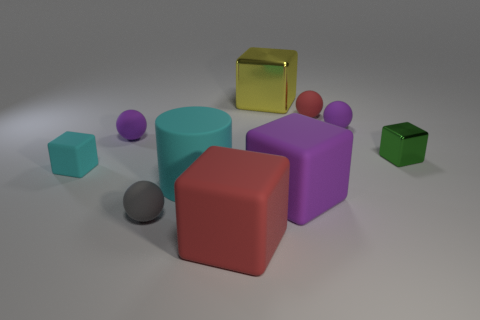What is the color of the small metal cube?
Your response must be concise. Green. There is a ball that is left of the gray thing; does it have the same color as the rubber sphere that is right of the red matte ball?
Keep it short and to the point. Yes. There is a cyan rubber thing that is the same shape as the small green metal object; what is its size?
Your response must be concise. Small. Is there a tiny cube of the same color as the cylinder?
Make the answer very short. Yes. What is the material of the cube that is the same color as the large cylinder?
Make the answer very short. Rubber. What number of large rubber cylinders have the same color as the tiny rubber block?
Provide a short and direct response. 1. What number of things are purple things on the right side of the gray ball or big brown matte spheres?
Make the answer very short. 2. What color is the cylinder that is made of the same material as the tiny red object?
Keep it short and to the point. Cyan. Is there a red ball that has the same size as the green metallic block?
Your answer should be compact. Yes. How many objects are either purple matte objects that are to the right of the red matte cube or purple objects left of the red ball?
Make the answer very short. 3. 